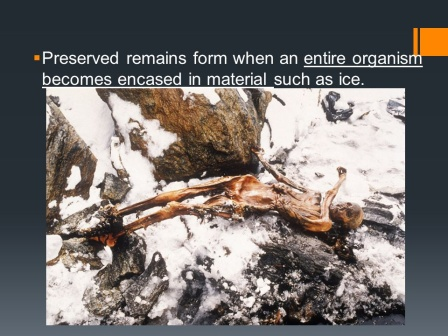Describe the following image. The image captures a mesmerizing scene of natural preservation. At the center of the frame lies the preserved skeleton of an organism, possibly a human, frozen in time. The skeleton is encased in ice, sprawled on its back with limbs extended as if clutching at life in its final moments. Its surrounding environment is harsh and rugged, consisting of dark, jagged rocks sporadically covered in patches of snow and ice that lend a stark contrast to the scene. The text in the top left corner of the image offers an explanation: 'Preserved remains form when an entire organism becomes encased in material such as ice.' This annotation not only explains the process that led to this remarkable preservation but also hints at the scientific importance of such phenomena. This compelling visual narrative not only shows the power of nature's preserving capabilities but also opens a window into understanding life's survival and demise in extreme conditions. 